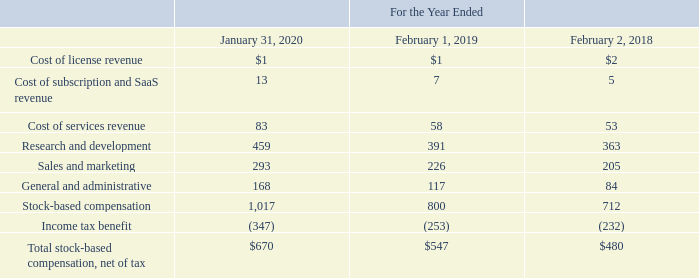Stock-Based Compensation
The following table summarizes the components of total stock-based compensation included in VMware’s consolidated statements of income during the periods presented (table in millions):
As of January 31, 2020, the total unrecognized compensation cost for stock options and restricted stock was $1.8 billion and will be recognized through fiscal 2024 with a weighted-average remaining period of 1.5 years. Stock-based compensation related to VMware equity awards held by VMware employees is recognized on VMware’s consolidated statements of income over the awards’ requisite service periods.
What was the total unrecognized compensation cost for stock options and restricted stock as of 2020? $1.8 billion. Which years does the table provide information for  the components of total stock-based compensation included in VMware’s consolidated statements of income? 2020, 2019, 2018. What was the cost of license revenue in 2018?
Answer scale should be: million. 2. Which years did Stock-based compensation exceed $1,000 million? (2020:1,017)
Answer: 2020. What was the change in the Cost of subscription and SaaS revenue between 2018 and 2019?
Answer scale should be: million. 7-5
Answer: 2. What was the percentage change in Total stock-based compensation, net of tax between 2019 and 2020?
Answer scale should be: percent. (670-547)/547
Answer: 22.49. 